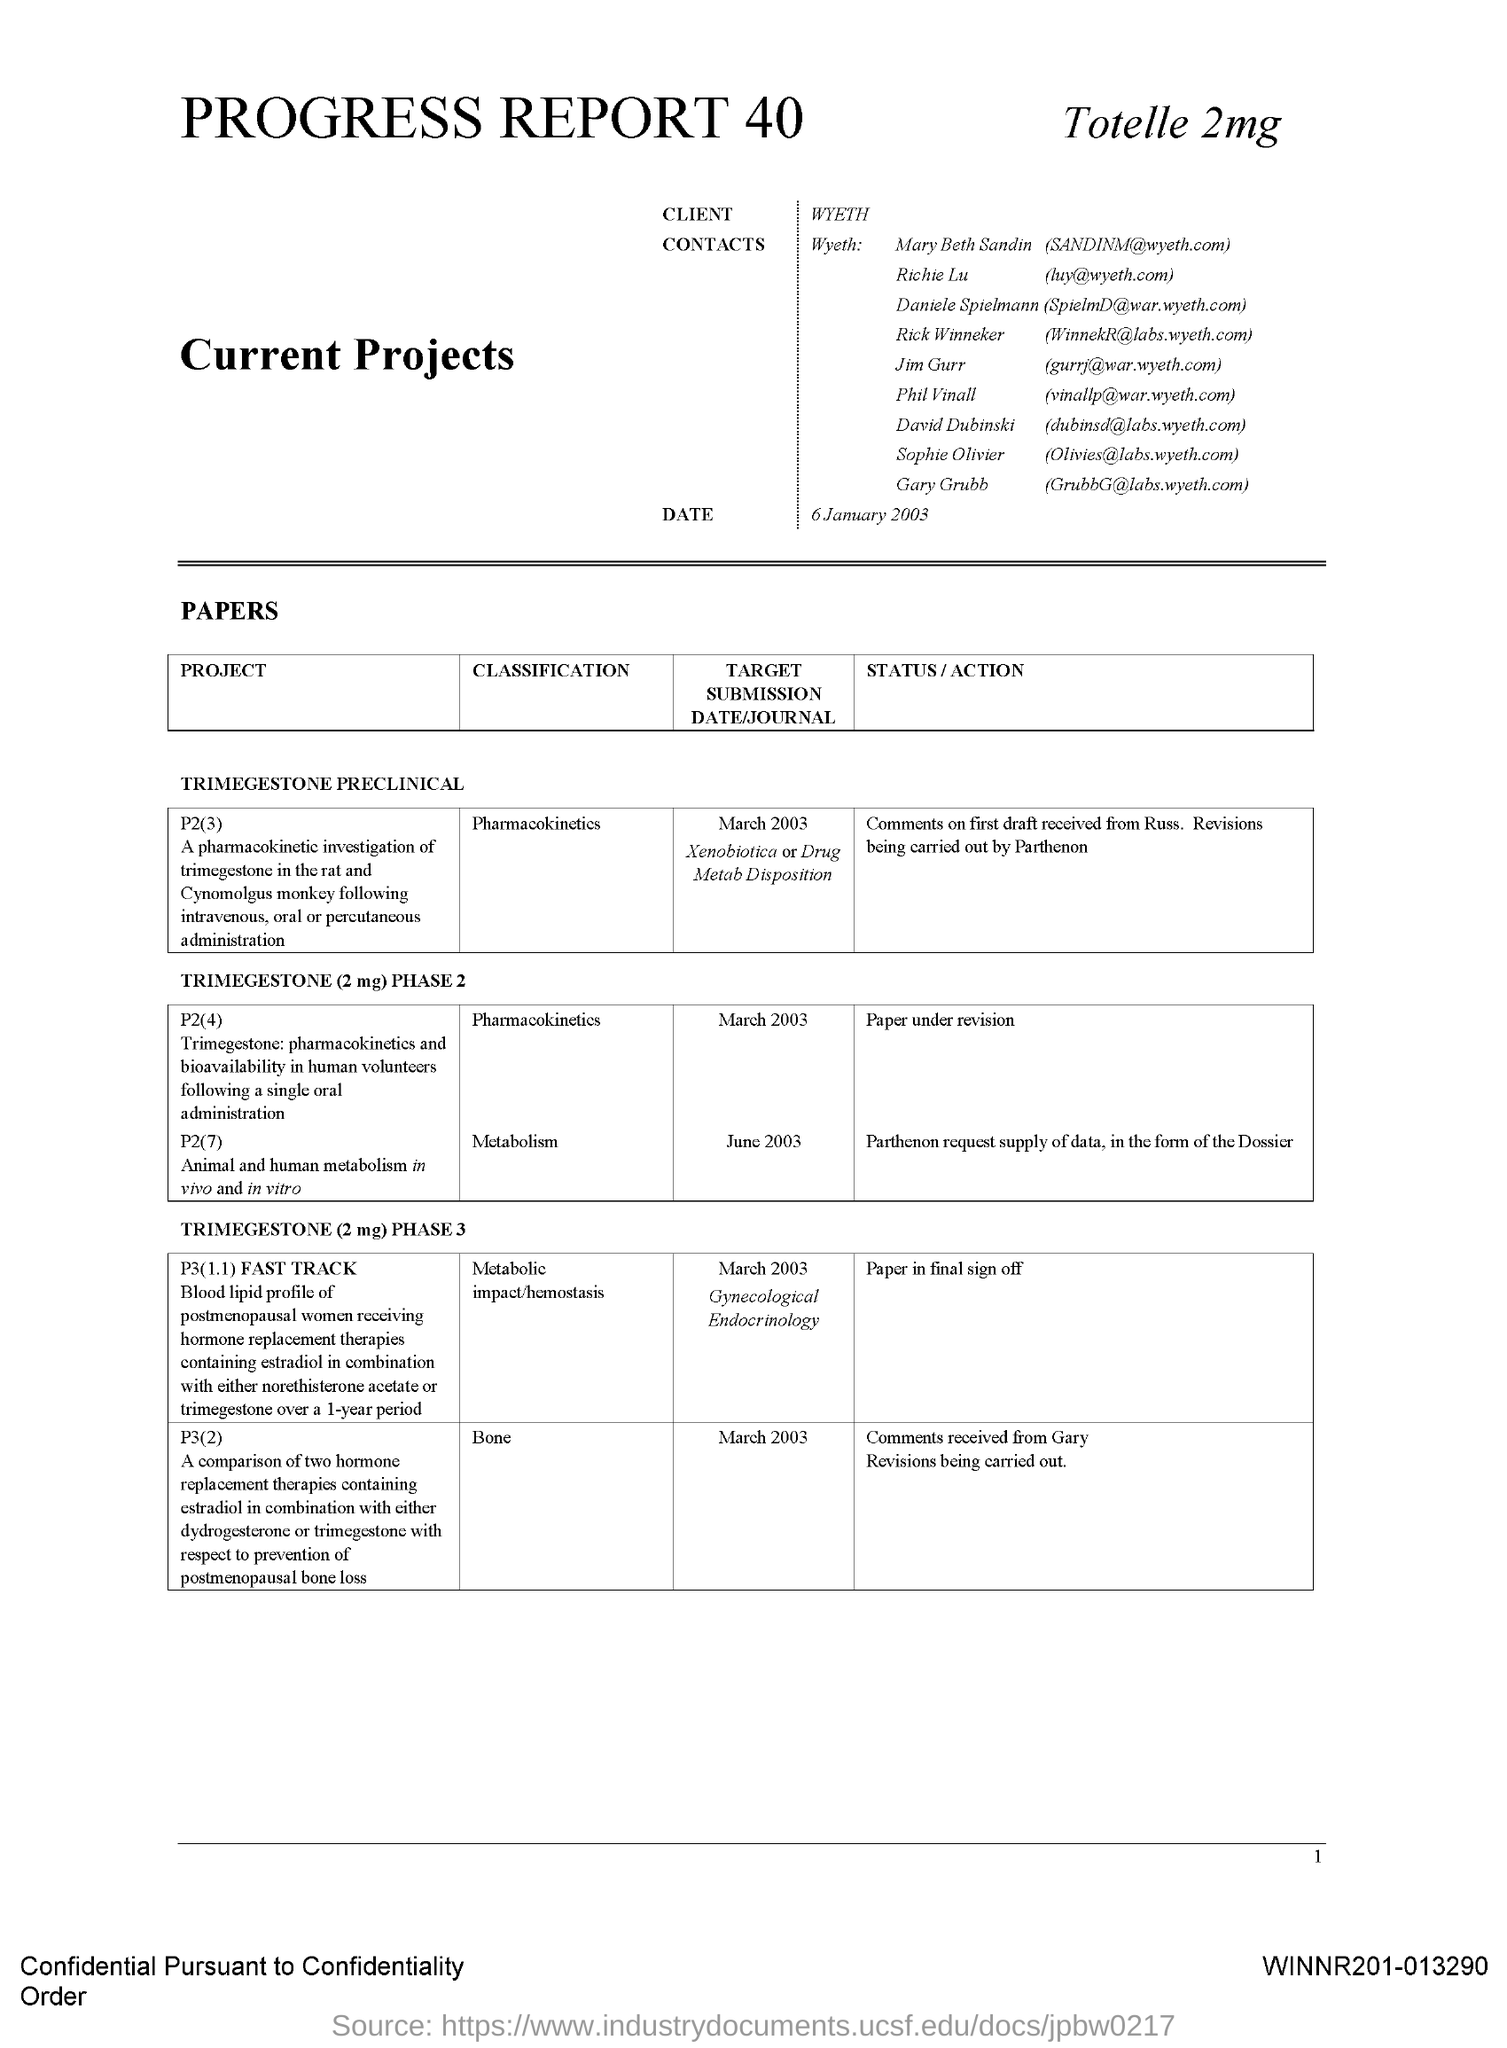Who is the Client?
Provide a succinct answer. Wyeth. 